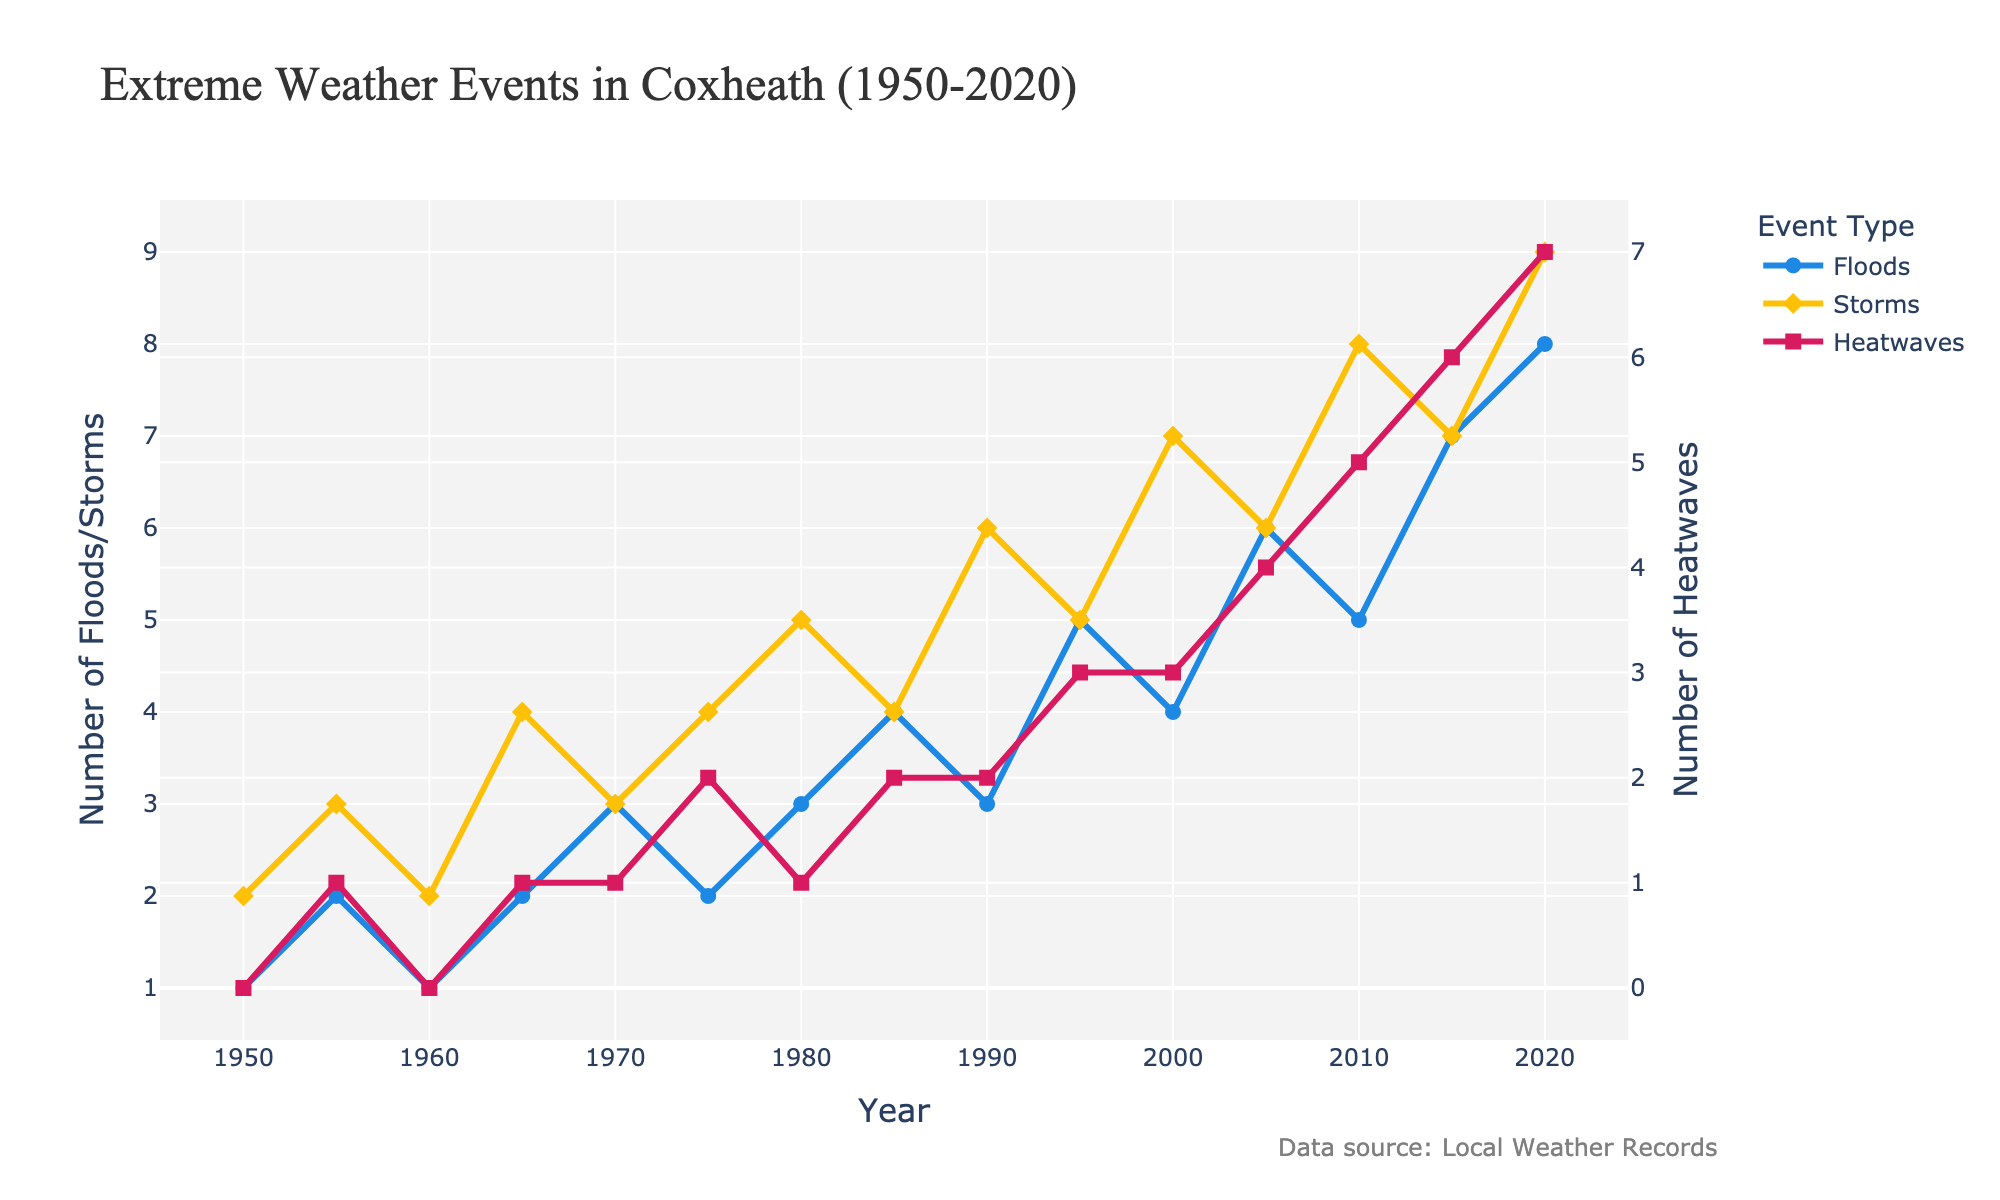What is the trend of heatwaves in Coxheath from 1950 to 2020? Examine the line representing heatwaves, which increases from 0 in 1950 to 7 in 2020, showing an upward trend.
Answer: Upward trend Which type of extreme weather event had the highest increase over the years? Compare the increases: Heatwaves from 0 to 7 (7), Storms from 2 to 9 (7), and Floods from 1 to 8 (7). All had the same numerical increase but heatwaves increased more proportionally as they started from 0.
Answer: Heatwaves In which year did the number of floods first surpass the number of storms? Look at the lines for floods and storms. Floods first surpass storms in 2020.
Answer: 2020 What is the average number of floods between 1950 and 2020? Sum the numbers of floods (1+2+1+2+3+2+3+4+3+5+4+6+5+7+8 = 56) and divide by the count of years (15). Thus, 56/15 ≈ 3.73.
Answer: 3.73 What was the frequency of storms in the year 2005? Locate the point in the storms line at the year 2005, which is at 6.
Answer: 6 How many more heatwaves occurred in 2020 compared to 1950? Subtract the number of heatwaves in 1950 (0) from the number in 2020 (7). Thus, 7 - 0 = 7.
Answer: 7 During which decade did storms see the highest increase? Calculate the differences per decade: 
1950s (3-2 = 1), 
1960s (4-2 = 2), 
1970s (4-3 = 1), 
1980s (5-4 = 1), 
1990s (6-5 = 1), 
2000s (7-6 = 1), 
2010s (8-7 = 1). 
The 1960s had the highest increase of 2.
Answer: 1960s What is the difference between the number of storms and floods in 1990? Locate values for 1990: Storms = 6, Floods = 3. Subtract the number of floods from the number of storms: 6 - 3 = 3.
Answer: 3 Which event type had the most occurrences in 2010? Check the values for 2010: Floods = 5, Storms = 8, Heatwaves = 5. Therefore, storms had the most occurrences with 8.
Answer: Storms In which years did the number of heatwaves and floods equal the same amount? Identify points where heatwaves and floods coincide: In 1975 and 1985, both lines intersect at (2, 2).
Answer: 1975 and 1985 